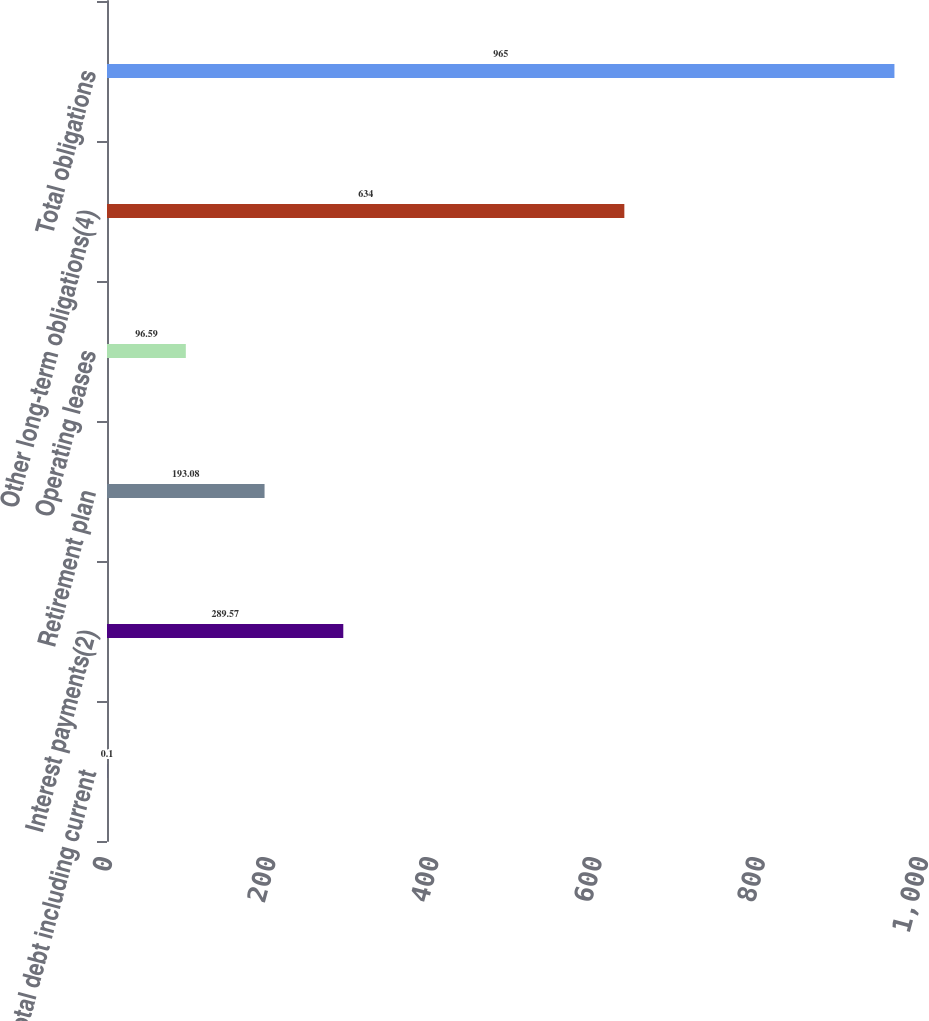Convert chart. <chart><loc_0><loc_0><loc_500><loc_500><bar_chart><fcel>Total debt including current<fcel>Interest payments(2)<fcel>Retirement plan<fcel>Operating leases<fcel>Other long-term obligations(4)<fcel>Total obligations<nl><fcel>0.1<fcel>289.57<fcel>193.08<fcel>96.59<fcel>634<fcel>965<nl></chart> 